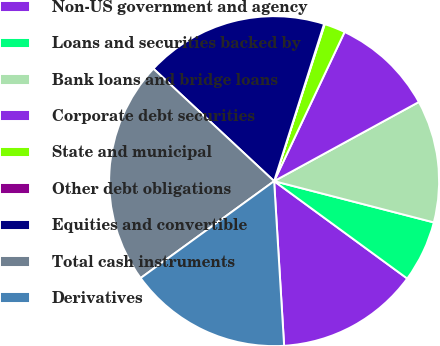<chart> <loc_0><loc_0><loc_500><loc_500><pie_chart><fcel>Non-US government and agency<fcel>Loans and securities backed by<fcel>Bank loans and bridge loans<fcel>Corporate debt securities<fcel>State and municipal<fcel>Other debt obligations<fcel>Equities and convertible<fcel>Total cash instruments<fcel>Derivatives<nl><fcel>13.98%<fcel>6.03%<fcel>11.99%<fcel>10.01%<fcel>2.06%<fcel>0.07%<fcel>17.96%<fcel>21.93%<fcel>15.97%<nl></chart> 